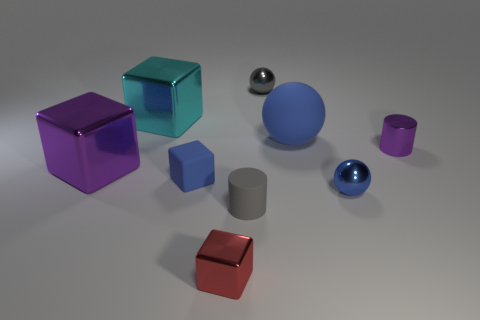There is a large thing that is the same color as the shiny cylinder; what shape is it?
Your response must be concise. Cube. Is the gray cylinder made of the same material as the small purple cylinder?
Offer a terse response. No. What is the large object that is on the left side of the gray rubber cylinder and right of the purple cube made of?
Ensure brevity in your answer.  Metal. Is there a gray thing made of the same material as the tiny gray cylinder?
Your answer should be compact. No. What is the material of the tiny block that is the same color as the rubber ball?
Your answer should be compact. Rubber. Is the tiny cylinder that is on the left side of the blue matte sphere made of the same material as the large thing that is on the right side of the big cyan block?
Your answer should be compact. Yes. Is the number of tiny metal spheres greater than the number of big cyan matte objects?
Keep it short and to the point. Yes. The small rubber object on the left side of the small cylinder left of the blue matte object that is to the right of the tiny red metallic cube is what color?
Offer a very short reply. Blue. There is a tiny block that is behind the tiny blue metal thing; is it the same color as the metallic sphere to the right of the small gray shiny thing?
Make the answer very short. Yes. What number of blue objects are in front of the gray object that is behind the cyan metal cube?
Provide a short and direct response. 3. 